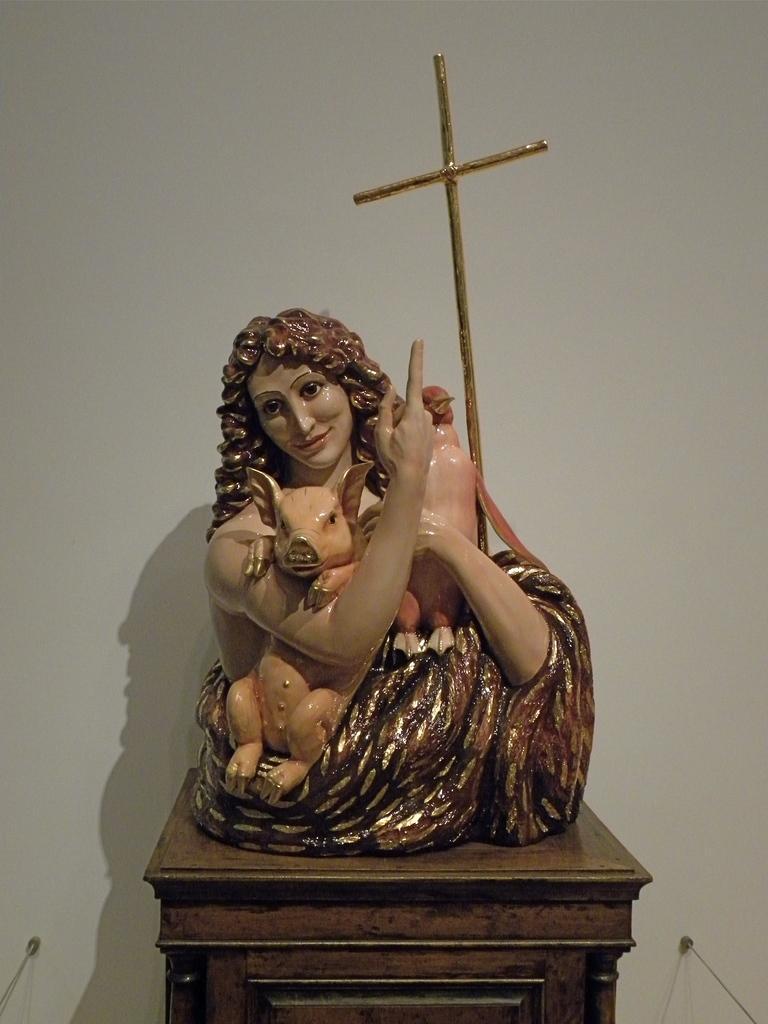In one or two sentences, can you explain what this image depicts? In the foreground of this image, there is a sculpture on a table and a wall in the background. 